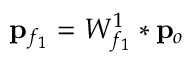<formula> <loc_0><loc_0><loc_500><loc_500>{ p } _ { f _ { 1 } } = W _ { f _ { 1 } } ^ { 1 } * { p } _ { o }</formula> 